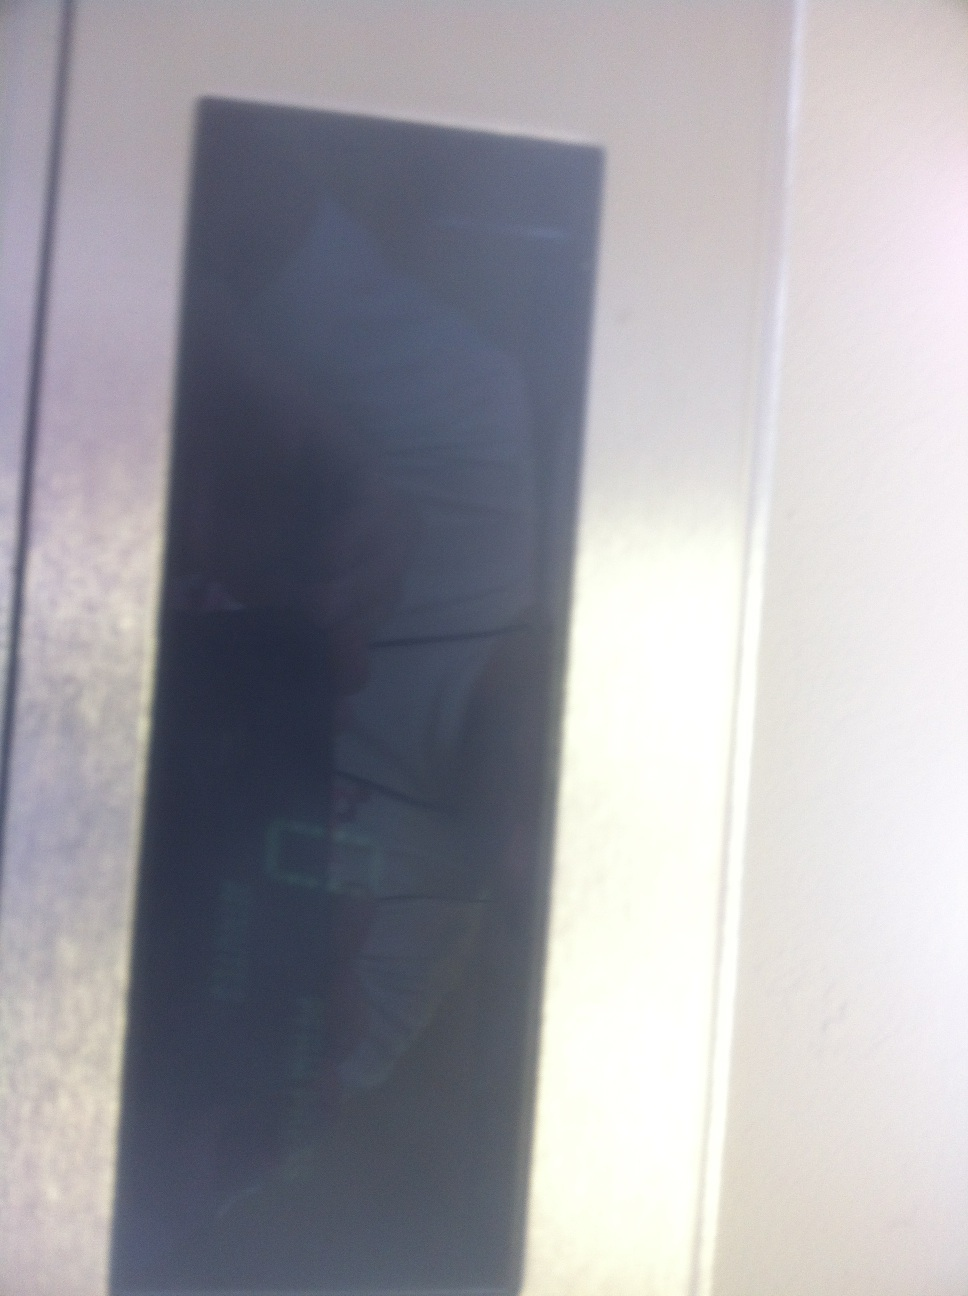Does the display provide any contextual information about its location or purpose? The display itself is ambiguous, but its sleek design and digital nature suggest it could be part of an electronic device, possibly a control panel or a digital readout in a technological or industrial environment. However, the exact purpose or any specific contextual information is not clearly discernible from the image alone. 